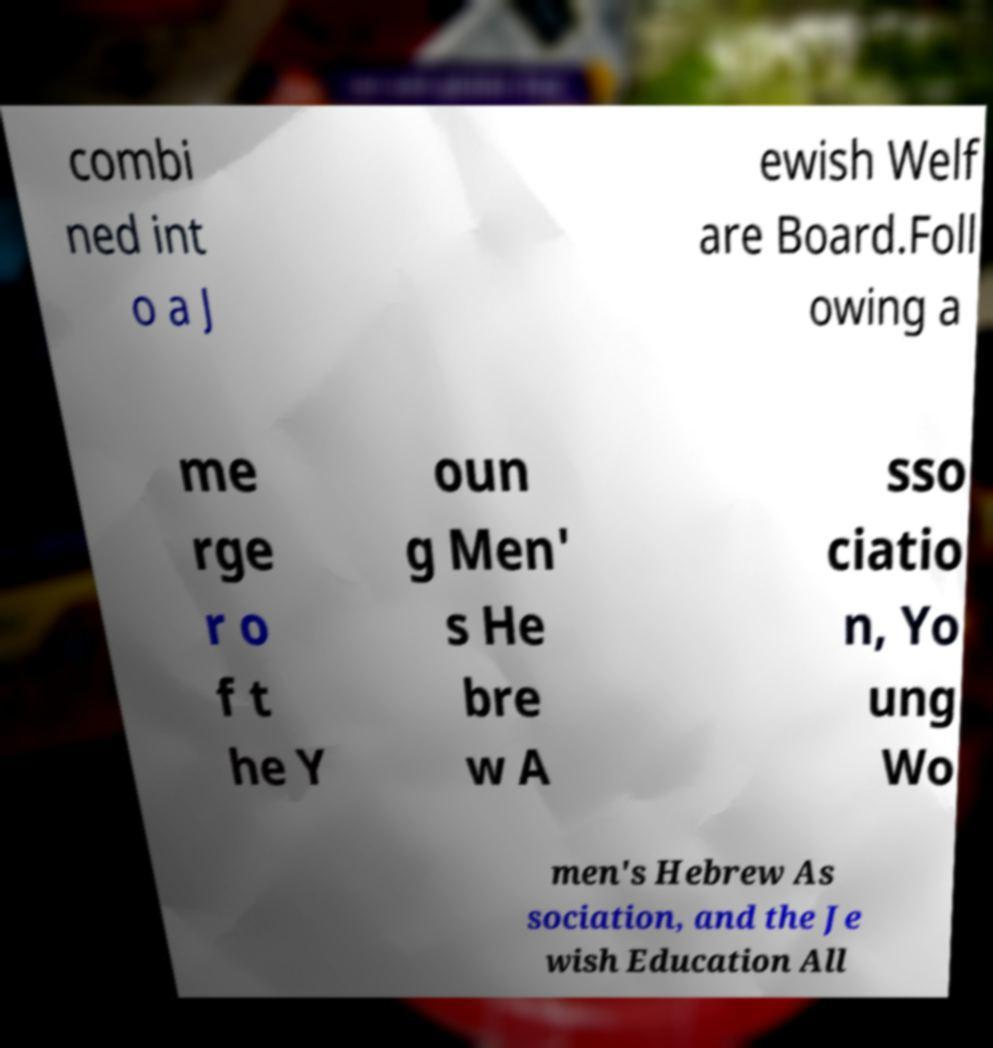Please identify and transcribe the text found in this image. combi ned int o a J ewish Welf are Board.Foll owing a me rge r o f t he Y oun g Men' s He bre w A sso ciatio n, Yo ung Wo men's Hebrew As sociation, and the Je wish Education All 